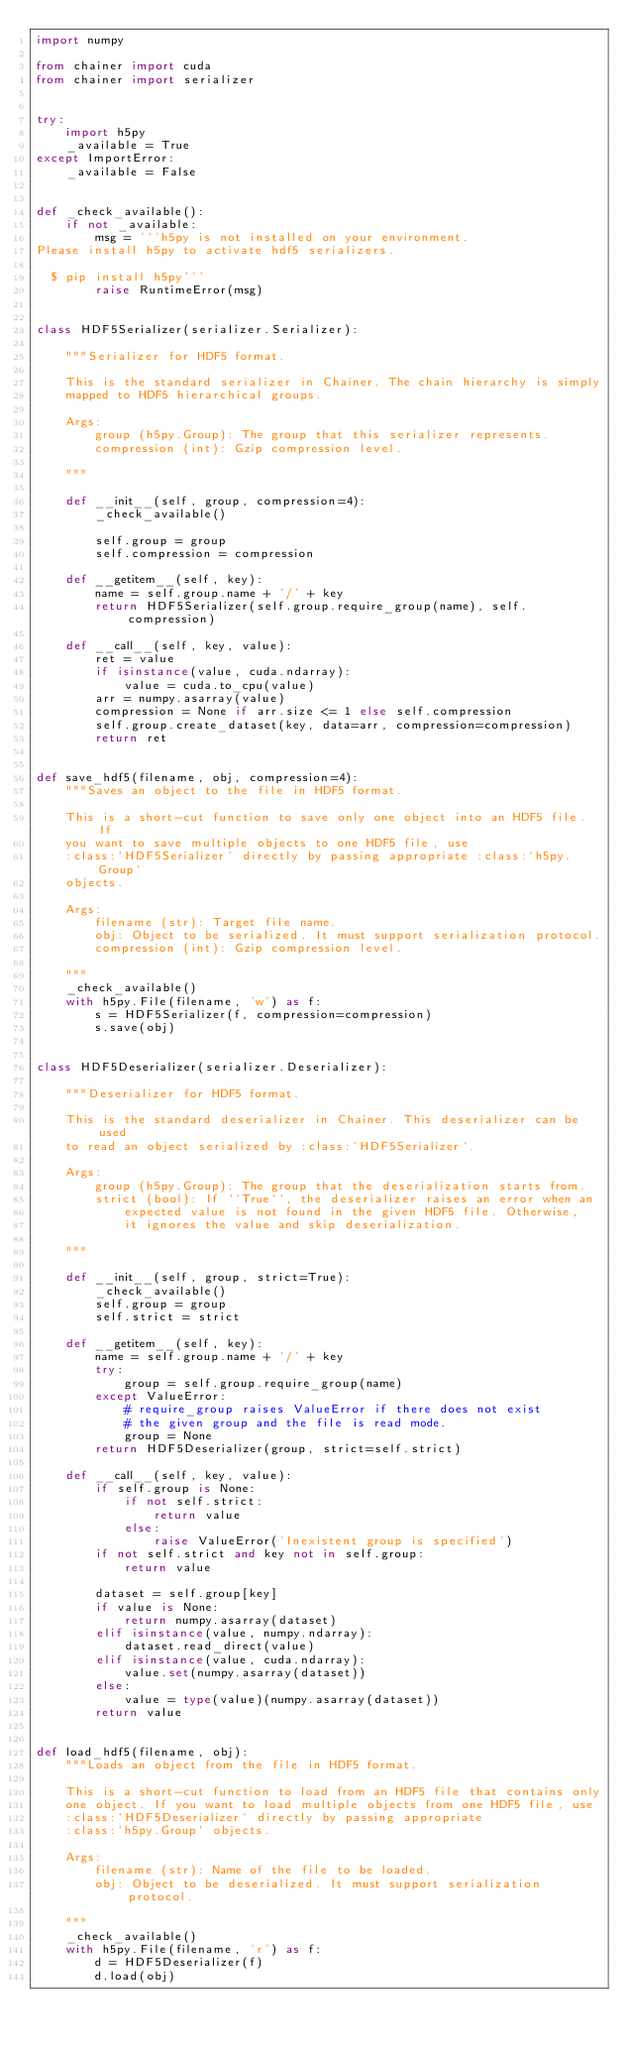<code> <loc_0><loc_0><loc_500><loc_500><_Python_>import numpy

from chainer import cuda
from chainer import serializer


try:
    import h5py
    _available = True
except ImportError:
    _available = False


def _check_available():
    if not _available:
        msg = '''h5py is not installed on your environment.
Please install h5py to activate hdf5 serializers.

  $ pip install h5py'''
        raise RuntimeError(msg)


class HDF5Serializer(serializer.Serializer):

    """Serializer for HDF5 format.

    This is the standard serializer in Chainer. The chain hierarchy is simply
    mapped to HDF5 hierarchical groups.

    Args:
        group (h5py.Group): The group that this serializer represents.
        compression (int): Gzip compression level.

    """

    def __init__(self, group, compression=4):
        _check_available()

        self.group = group
        self.compression = compression

    def __getitem__(self, key):
        name = self.group.name + '/' + key
        return HDF5Serializer(self.group.require_group(name), self.compression)

    def __call__(self, key, value):
        ret = value
        if isinstance(value, cuda.ndarray):
            value = cuda.to_cpu(value)
        arr = numpy.asarray(value)
        compression = None if arr.size <= 1 else self.compression
        self.group.create_dataset(key, data=arr, compression=compression)
        return ret


def save_hdf5(filename, obj, compression=4):
    """Saves an object to the file in HDF5 format.

    This is a short-cut function to save only one object into an HDF5 file. If
    you want to save multiple objects to one HDF5 file, use
    :class:`HDF5Serializer` directly by passing appropriate :class:`h5py.Group`
    objects.

    Args:
        filename (str): Target file name.
        obj: Object to be serialized. It must support serialization protocol.
        compression (int): Gzip compression level.

    """
    _check_available()
    with h5py.File(filename, 'w') as f:
        s = HDF5Serializer(f, compression=compression)
        s.save(obj)


class HDF5Deserializer(serializer.Deserializer):

    """Deserializer for HDF5 format.

    This is the standard deserializer in Chainer. This deserializer can be used
    to read an object serialized by :class:`HDF5Serializer`.

    Args:
        group (h5py.Group): The group that the deserialization starts from.
        strict (bool): If ``True``, the deserializer raises an error when an
            expected value is not found in the given HDF5 file. Otherwise,
            it ignores the value and skip deserialization.

    """

    def __init__(self, group, strict=True):
        _check_available()
        self.group = group
        self.strict = strict

    def __getitem__(self, key):
        name = self.group.name + '/' + key
        try:
            group = self.group.require_group(name)
        except ValueError:
            # require_group raises ValueError if there does not exist
            # the given group and the file is read mode.
            group = None
        return HDF5Deserializer(group, strict=self.strict)

    def __call__(self, key, value):
        if self.group is None:
            if not self.strict:
                return value
            else:
                raise ValueError('Inexistent group is specified')
        if not self.strict and key not in self.group:
            return value

        dataset = self.group[key]
        if value is None:
            return numpy.asarray(dataset)
        elif isinstance(value, numpy.ndarray):
            dataset.read_direct(value)
        elif isinstance(value, cuda.ndarray):
            value.set(numpy.asarray(dataset))
        else:
            value = type(value)(numpy.asarray(dataset))
        return value


def load_hdf5(filename, obj):
    """Loads an object from the file in HDF5 format.

    This is a short-cut function to load from an HDF5 file that contains only
    one object. If you want to load multiple objects from one HDF5 file, use
    :class:`HDF5Deserializer` directly by passing appropriate
    :class:`h5py.Group` objects.

    Args:
        filename (str): Name of the file to be loaded.
        obj: Object to be deserialized. It must support serialization protocol.

    """
    _check_available()
    with h5py.File(filename, 'r') as f:
        d = HDF5Deserializer(f)
        d.load(obj)
</code> 